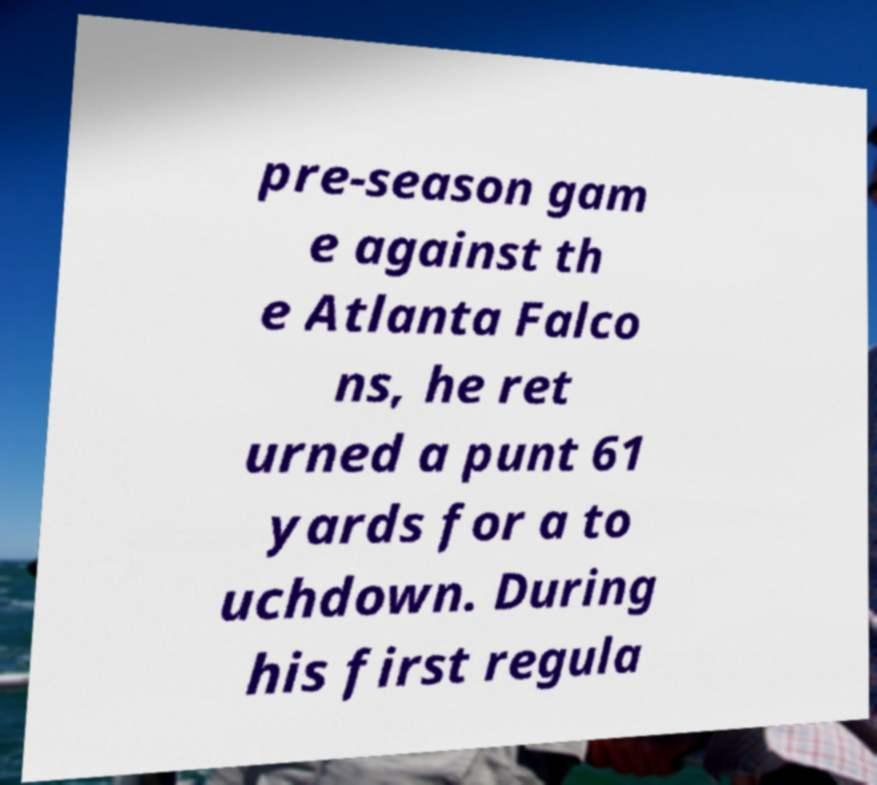I need the written content from this picture converted into text. Can you do that? pre-season gam e against th e Atlanta Falco ns, he ret urned a punt 61 yards for a to uchdown. During his first regula 